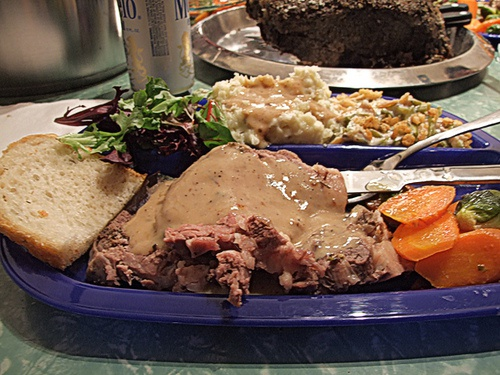Describe the objects in this image and their specific colors. I can see carrot in black, brown, maroon, and red tones, knife in black, ivory, and tan tones, carrot in black, orange, red, and tan tones, carrot in black, red, orange, and brown tones, and fork in black, white, darkgray, and tan tones in this image. 